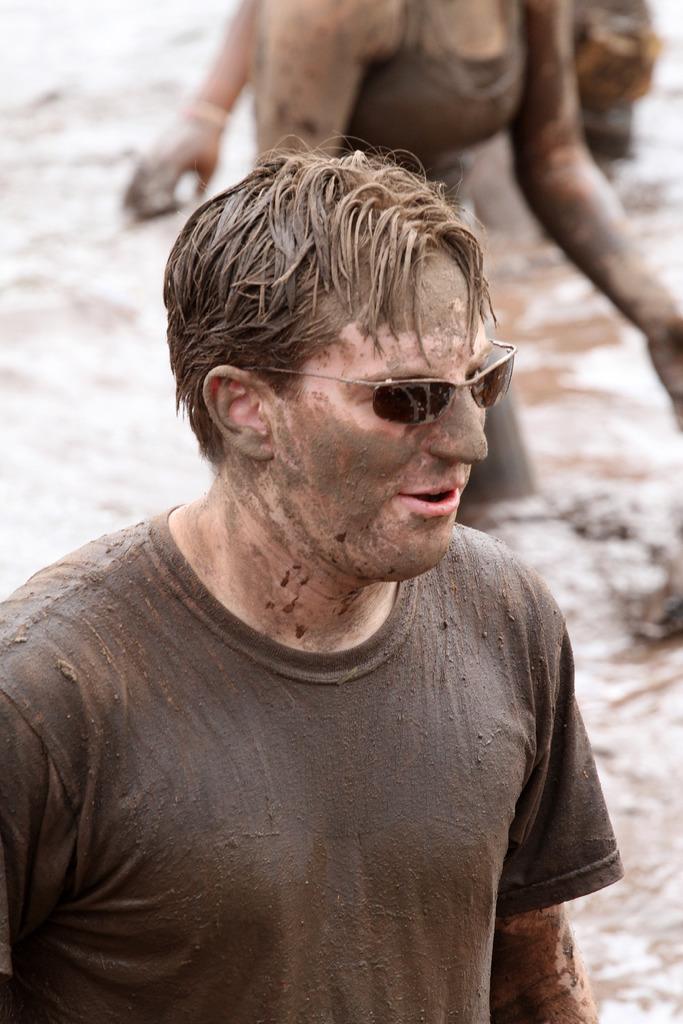How would you summarize this image in a sentence or two? In this image we can see a group of people standing. One person is wearing goggles. 